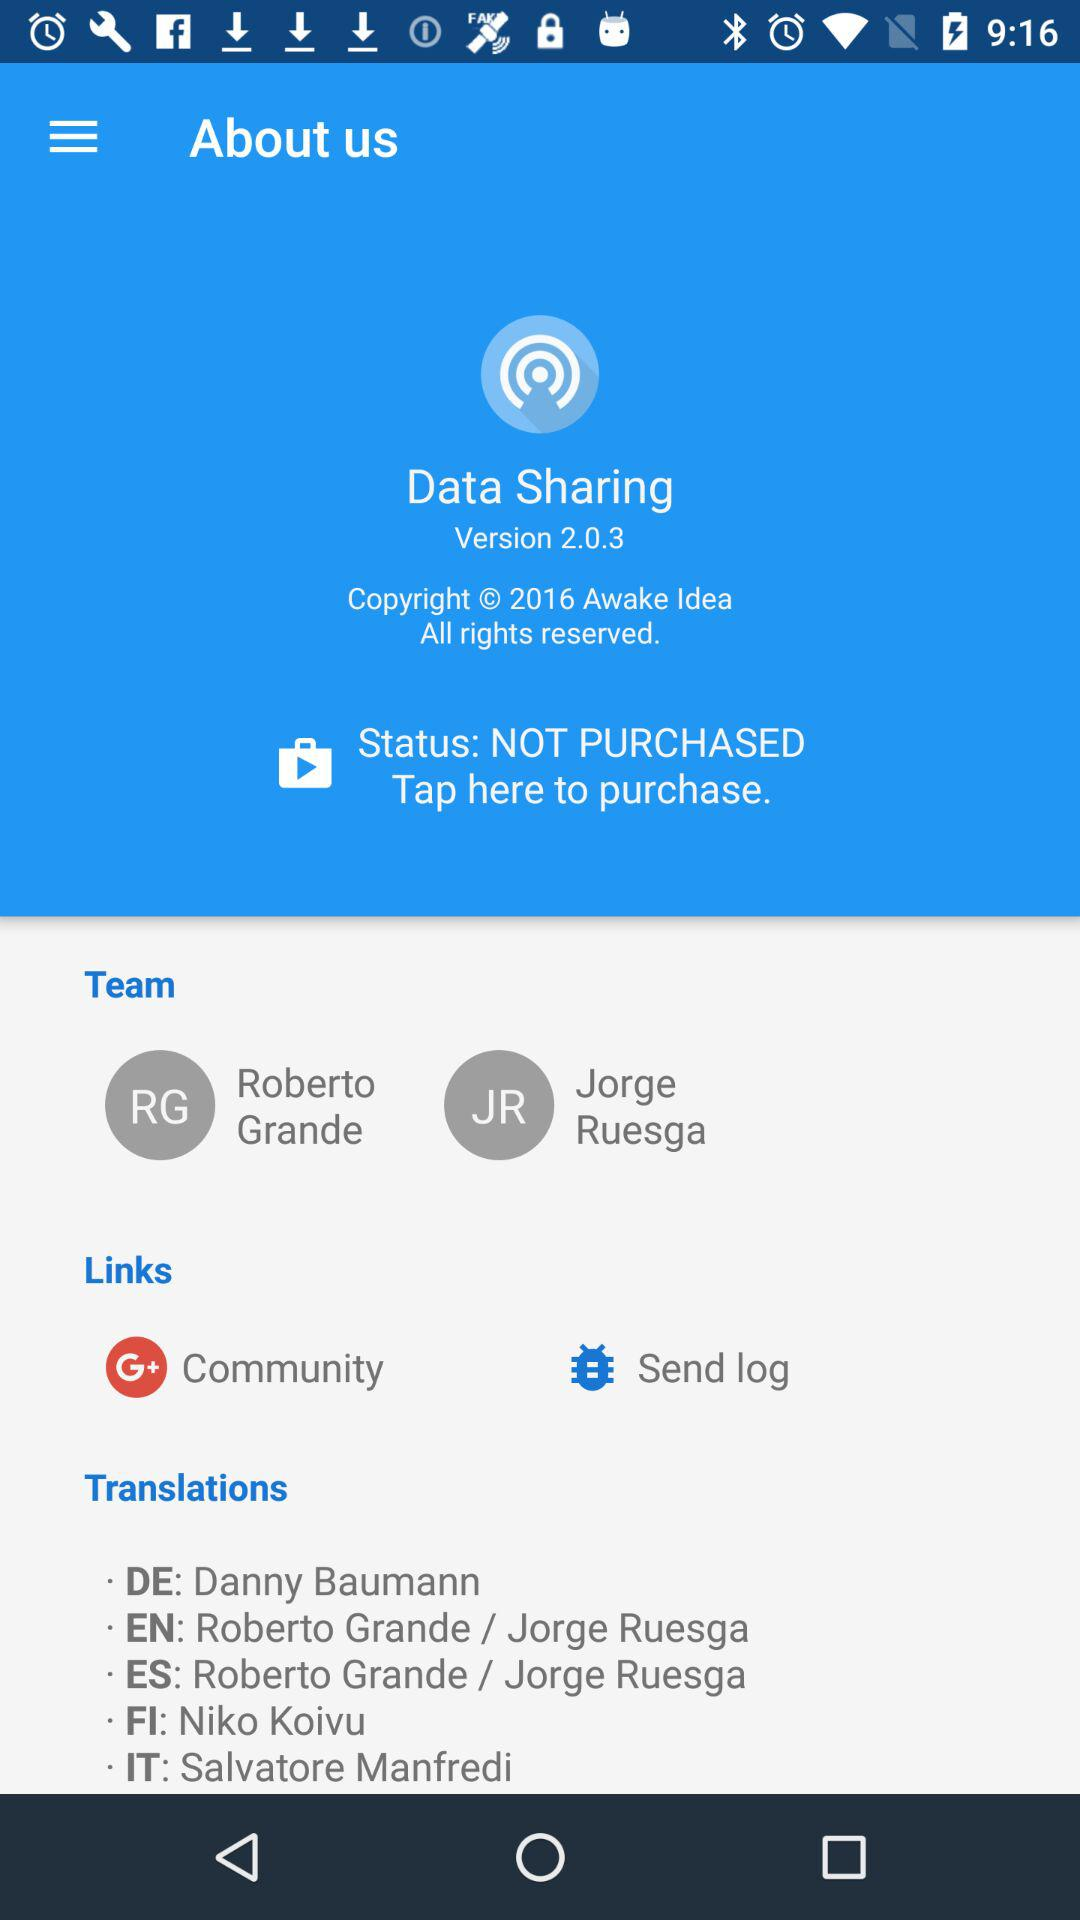What is the version of "Data Sharing"? The version is 2.0.3. 